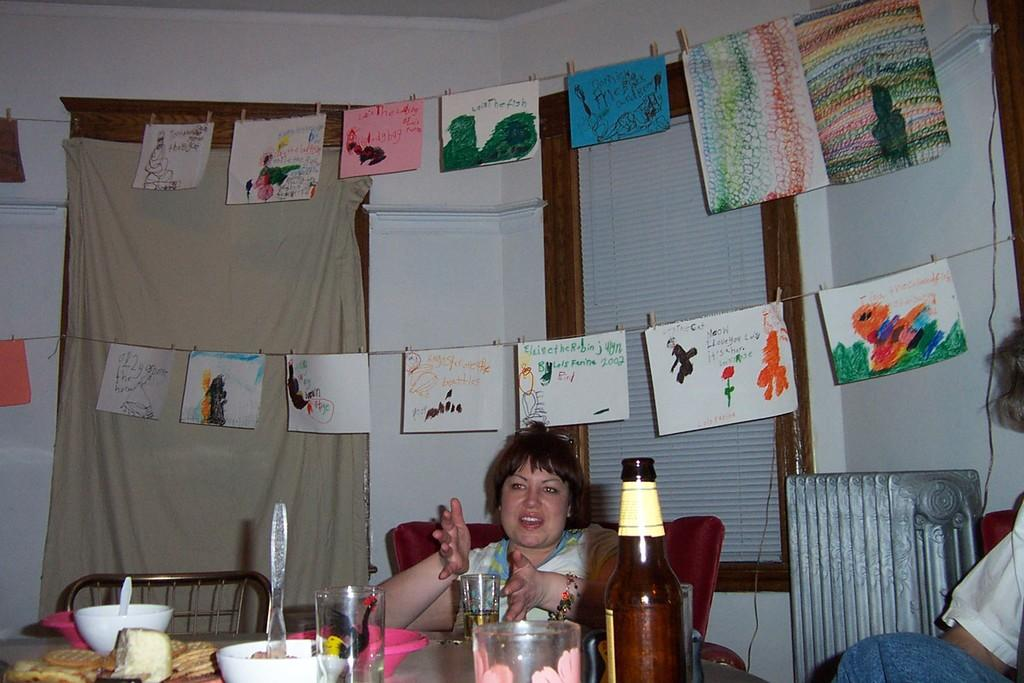What is the color of the wall in the image? The wall in the image is white. What can be seen on the wall in the image? There is a window on the wall in the image. What is the woman sitting on in the image? The woman is sitting on a chair in the image. What is on the table in the image? There is a bottle, a glass, and a bowl on the table in the image. What is the woman holding in the image? The woman is holding a cloth in the image. What is on the floor in the image? There are papers on the floor in the image. How many fairies are flying around the woman in the image? There are no fairies present in the image. What type of current is flowing through the bottle in the image? There is no current flowing through the bottle in the image; it is a stationary object. 